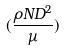Convert formula to latex. <formula><loc_0><loc_0><loc_500><loc_500>( \frac { \rho N D ^ { 2 } } { \mu } )</formula> 